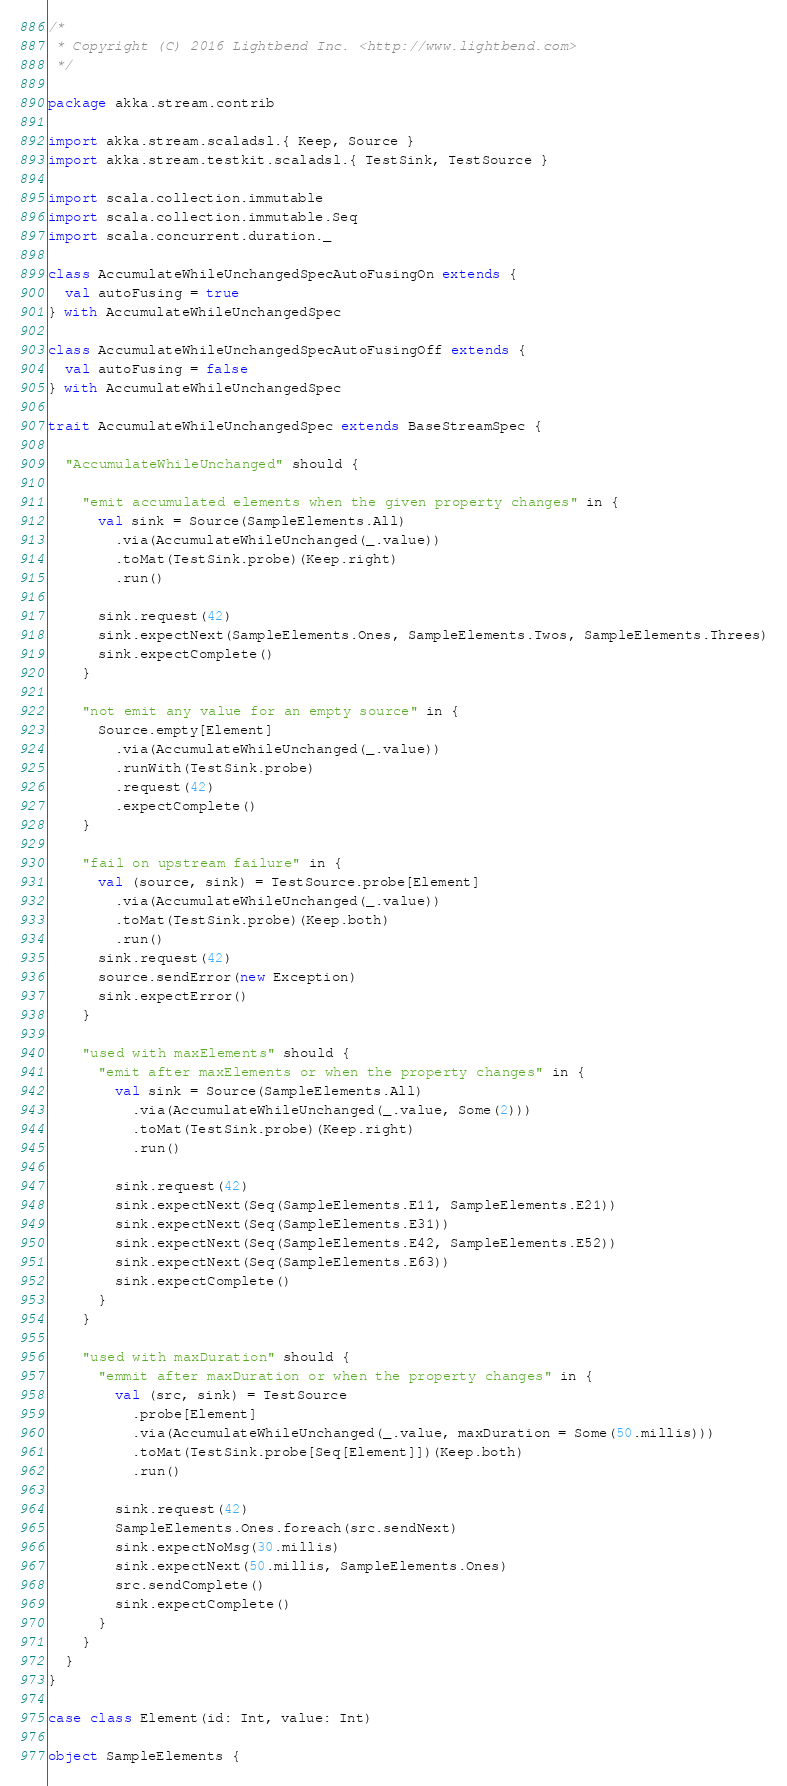Convert code to text. <code><loc_0><loc_0><loc_500><loc_500><_Scala_>/*
 * Copyright (C) 2016 Lightbend Inc. <http://www.lightbend.com>
 */

package akka.stream.contrib

import akka.stream.scaladsl.{ Keep, Source }
import akka.stream.testkit.scaladsl.{ TestSink, TestSource }

import scala.collection.immutable
import scala.collection.immutable.Seq
import scala.concurrent.duration._

class AccumulateWhileUnchangedSpecAutoFusingOn extends {
  val autoFusing = true
} with AccumulateWhileUnchangedSpec

class AccumulateWhileUnchangedSpecAutoFusingOff extends {
  val autoFusing = false
} with AccumulateWhileUnchangedSpec

trait AccumulateWhileUnchangedSpec extends BaseStreamSpec {

  "AccumulateWhileUnchanged" should {

    "emit accumulated elements when the given property changes" in {
      val sink = Source(SampleElements.All)
        .via(AccumulateWhileUnchanged(_.value))
        .toMat(TestSink.probe)(Keep.right)
        .run()

      sink.request(42)
      sink.expectNext(SampleElements.Ones, SampleElements.Twos, SampleElements.Threes)
      sink.expectComplete()
    }

    "not emit any value for an empty source" in {
      Source.empty[Element]
        .via(AccumulateWhileUnchanged(_.value))
        .runWith(TestSink.probe)
        .request(42)
        .expectComplete()
    }

    "fail on upstream failure" in {
      val (source, sink) = TestSource.probe[Element]
        .via(AccumulateWhileUnchanged(_.value))
        .toMat(TestSink.probe)(Keep.both)
        .run()
      sink.request(42)
      source.sendError(new Exception)
      sink.expectError()
    }

    "used with maxElements" should {
      "emit after maxElements or when the property changes" in {
        val sink = Source(SampleElements.All)
          .via(AccumulateWhileUnchanged(_.value, Some(2)))
          .toMat(TestSink.probe)(Keep.right)
          .run()

        sink.request(42)
        sink.expectNext(Seq(SampleElements.E11, SampleElements.E21))
        sink.expectNext(Seq(SampleElements.E31))
        sink.expectNext(Seq(SampleElements.E42, SampleElements.E52))
        sink.expectNext(Seq(SampleElements.E63))
        sink.expectComplete()
      }
    }

    "used with maxDuration" should {
      "emmit after maxDuration or when the property changes" in {
        val (src, sink) = TestSource
          .probe[Element]
          .via(AccumulateWhileUnchanged(_.value, maxDuration = Some(50.millis)))
          .toMat(TestSink.probe[Seq[Element]])(Keep.both)
          .run()

        sink.request(42)
        SampleElements.Ones.foreach(src.sendNext)
        sink.expectNoMsg(30.millis)
        sink.expectNext(50.millis, SampleElements.Ones)
        src.sendComplete()
        sink.expectComplete()
      }
    }
  }
}

case class Element(id: Int, value: Int)

object SampleElements {
</code> 